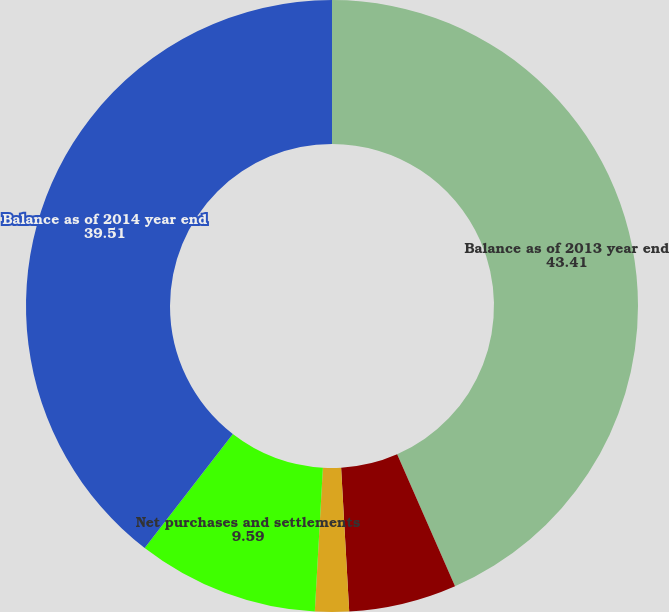Convert chart to OTSL. <chart><loc_0><loc_0><loc_500><loc_500><pie_chart><fcel>Balance as of 2013 year end<fcel>Realized gains on assets sold<fcel>Unrealized gains attributable<fcel>Net purchases and settlements<fcel>Balance as of 2014 year end<nl><fcel>43.41%<fcel>5.69%<fcel>1.79%<fcel>9.59%<fcel>39.51%<nl></chart> 